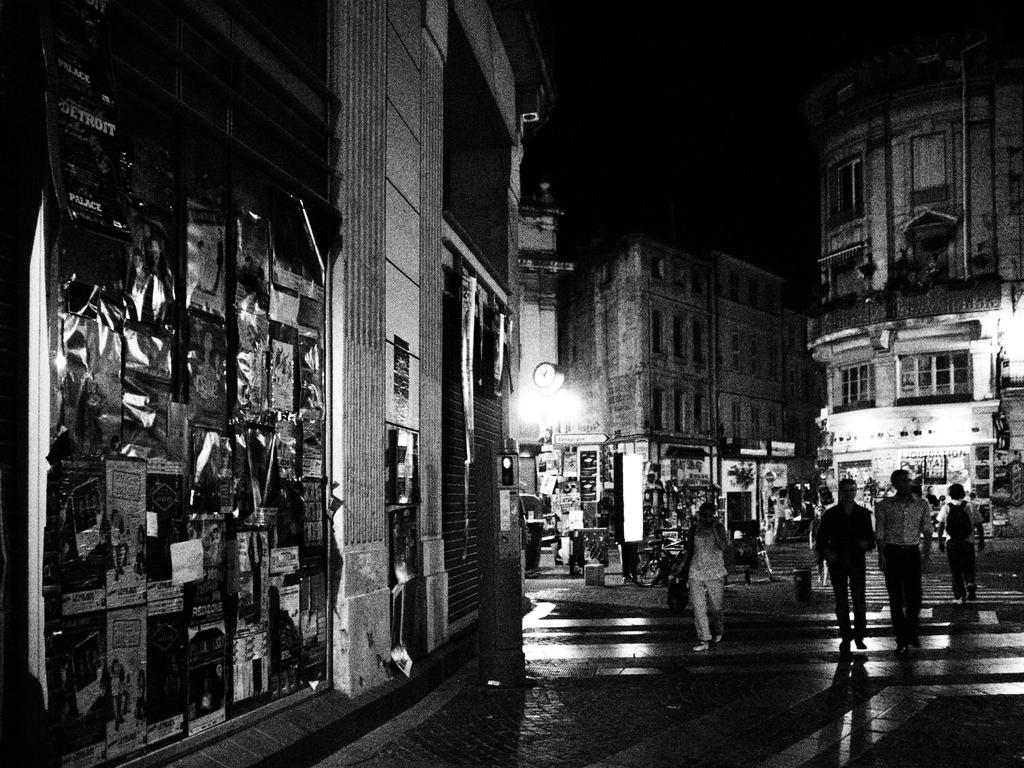What is the color scheme of the image? The image is black and white. What can be seen in the image besides the color scheme? There is a road in the image, along with people, buildings, and stores around the road. Can you read the note that is being passed between the people on the road? There is no note present in the image; it is a black and white image featuring a road, people, buildings, and stores. 